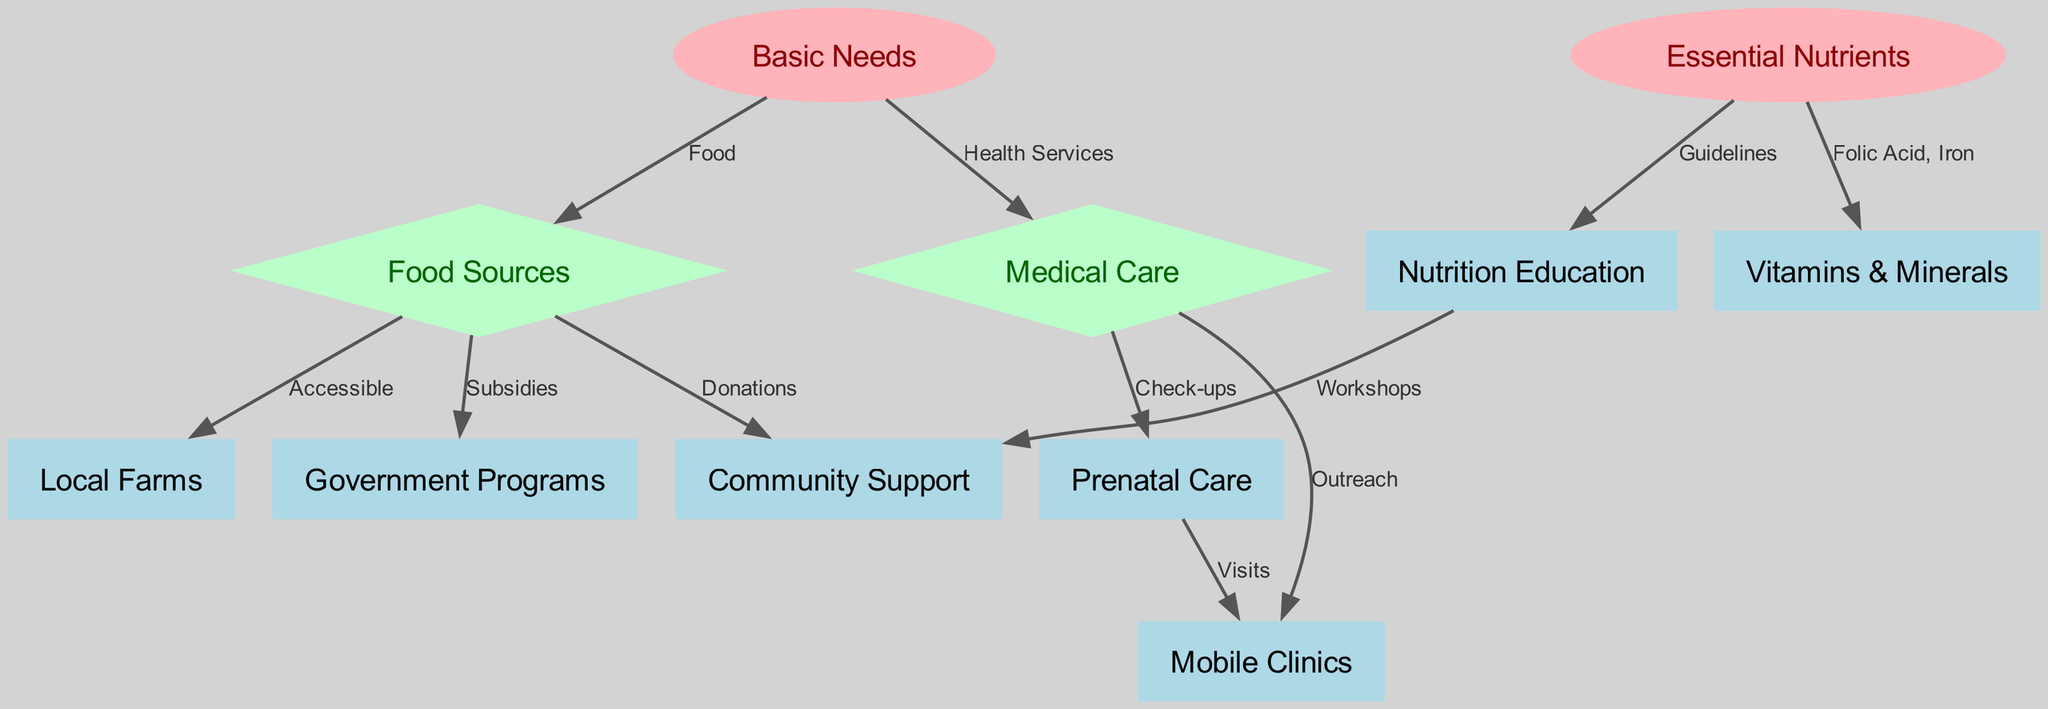What are the main components connected to basic needs? The diagram shows two components connected to basic needs: food sources and medical care. The edges clearly indicate that basic needs encompass both dimensions of nourishment and health services crucial for expecting mothers.
Answer: food sources, medical care How many nodes represent essential nutrients? In the diagram, there is one node specifically labeled as essential nutrients. This is clearly identifiable as it relates to the fundamental nutritional requirements during pregnancy.
Answer: 1 Which food source is marked as accessible? Looking at the diagram, the food sources node connects to local farms with the edge labeled 'Accessible', indicating that local farms are the identified accessible food source for nutritious food.
Answer: local farms What type of care is associated with medical care? The medical care node connects to the prenatal care node through an edge marked 'Check-ups'. This indicates that prenatal care is the specific type of medical care associated within this context.
Answer: prenatal care What is the relationship between essential nutrients and vitamins & minerals? The essential nutrients node leads to the vitamins and minerals node, with the edge labeled 'Folic Acid, Iron'. This indicates that vitamins and minerals are a specific type of essential nutrient needed during pregnancy.
Answer: vitamins & minerals How do community support and nutrition education interact? The nutrition education node connects to the community support node through the edge labeled 'Workshops'. This implies that workshops serve as a mechanism to bring community support and nutrition education together to aid pregnant women.
Answer: workshops What outreach method is connected to medical care? Within the diagram, the medical care node is connected to the mobile clinics node, indicated by the edge labeled 'Outreach'. This signifies that mobile clinics are a method of reaching pregnant women with medical care services.
Answer: mobile clinics Which program is mentioned as a source of subsidies? The diagram specifies that food sources connect to the government programs node with an edge labeled 'Subsidies', highlighting that government programs provide financial support for accessing food resources.
Answer: government programs How does nutrition education relate to essential nutrients? The nutrition education node is linked from the essential nutrients node with an edge labeled 'Guidelines', which indicates that nutrition education provides guidelines related to the essential nutrients necessary for pregnant women.
Answer: guidelines 